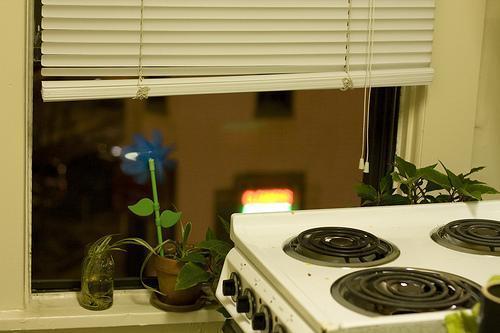How many ovens are there?
Give a very brief answer. 1. How many potted plants are on the windowsill?
Give a very brief answer. 3. 